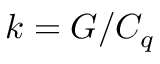<formula> <loc_0><loc_0><loc_500><loc_500>k = G / C _ { q }</formula> 